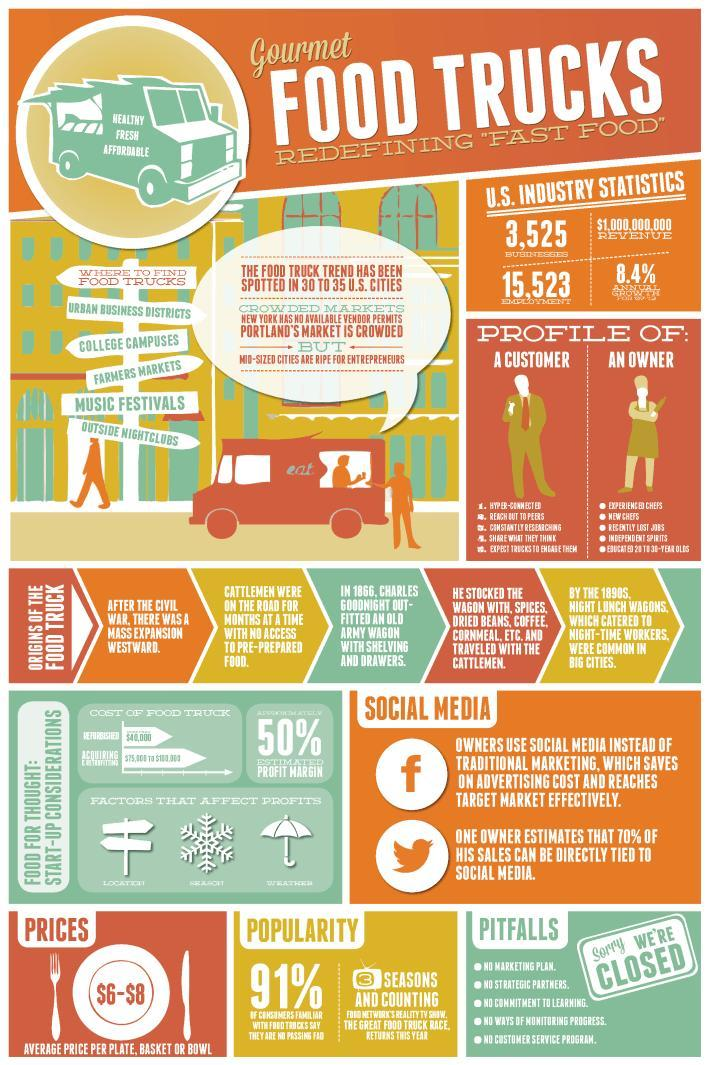How many factors can affect Food truck business profit?
Answer the question with a short phrase. 3 Which is the first and foremost place to find food trucks? Urban Business Districts How many social media logos are depicted in the infographic? 2 What is the advantage of buying food from Food Trucks? Healthy, Fresh, Affordable Which is the fourth place listed in the infographic to find food trucks? Music Festivals Which place is the best for Food Truck Start Ups? Mid-Sized Cities How many Food Truck jobs are there in U.S? 15,523 How many Food Truck Businesses are running in America? 3,525 What is the third Pitfall listed in the infographic? No commitment to learning What percentage of people in america are not familiar with food trucks? 9 